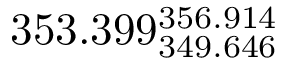<formula> <loc_0><loc_0><loc_500><loc_500>3 5 3 . 3 9 9 _ { 3 4 9 . 6 4 6 } ^ { 3 5 6 . 9 1 4 }</formula> 